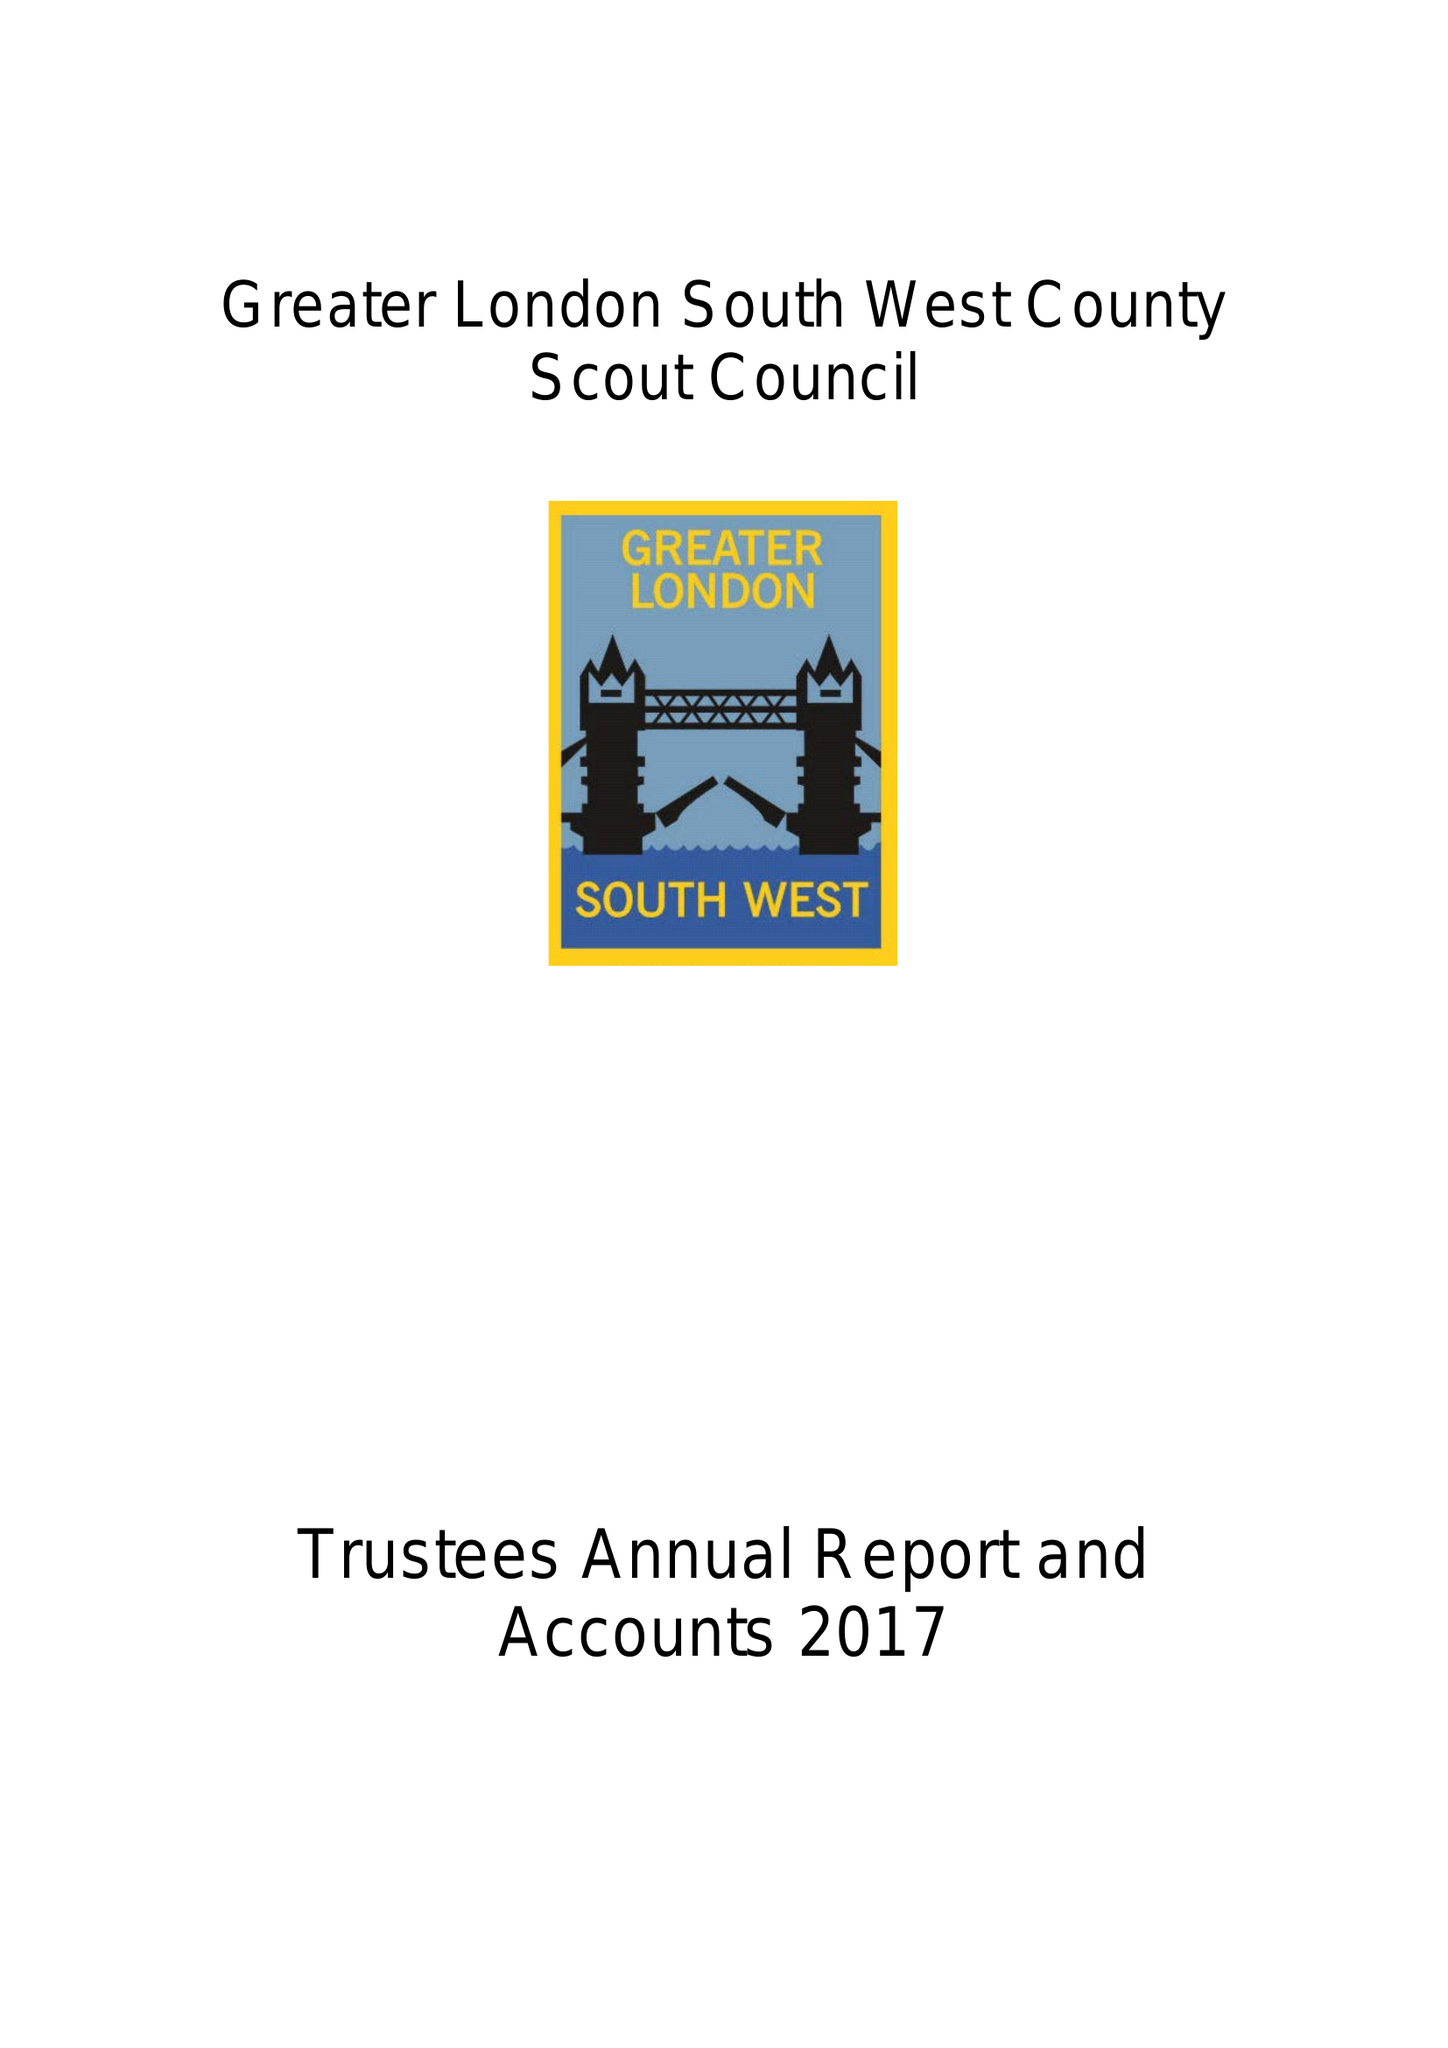What is the value for the spending_annually_in_british_pounds?
Answer the question using a single word or phrase. 118053.00 